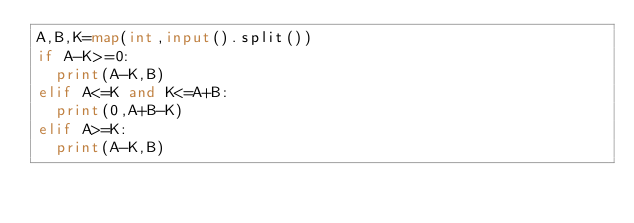Convert code to text. <code><loc_0><loc_0><loc_500><loc_500><_Python_>A,B,K=map(int,input().split())
if A-K>=0:
  print(A-K,B)
elif A<=K and K<=A+B:
  print(0,A+B-K)
elif A>=K:
  print(A-K,B)</code> 